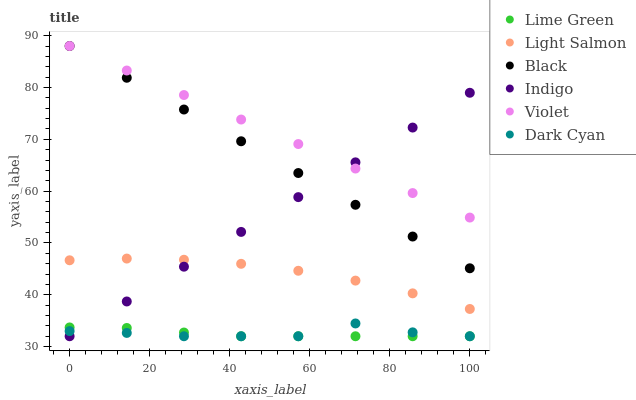Does Lime Green have the minimum area under the curve?
Answer yes or no. Yes. Does Violet have the maximum area under the curve?
Answer yes or no. Yes. Does Indigo have the minimum area under the curve?
Answer yes or no. No. Does Indigo have the maximum area under the curve?
Answer yes or no. No. Is Indigo the smoothest?
Answer yes or no. Yes. Is Dark Cyan the roughest?
Answer yes or no. Yes. Is Black the smoothest?
Answer yes or no. No. Is Black the roughest?
Answer yes or no. No. Does Indigo have the lowest value?
Answer yes or no. Yes. Does Black have the lowest value?
Answer yes or no. No. Does Violet have the highest value?
Answer yes or no. Yes. Does Indigo have the highest value?
Answer yes or no. No. Is Dark Cyan less than Light Salmon?
Answer yes or no. Yes. Is Black greater than Dark Cyan?
Answer yes or no. Yes. Does Dark Cyan intersect Lime Green?
Answer yes or no. Yes. Is Dark Cyan less than Lime Green?
Answer yes or no. No. Is Dark Cyan greater than Lime Green?
Answer yes or no. No. Does Dark Cyan intersect Light Salmon?
Answer yes or no. No. 